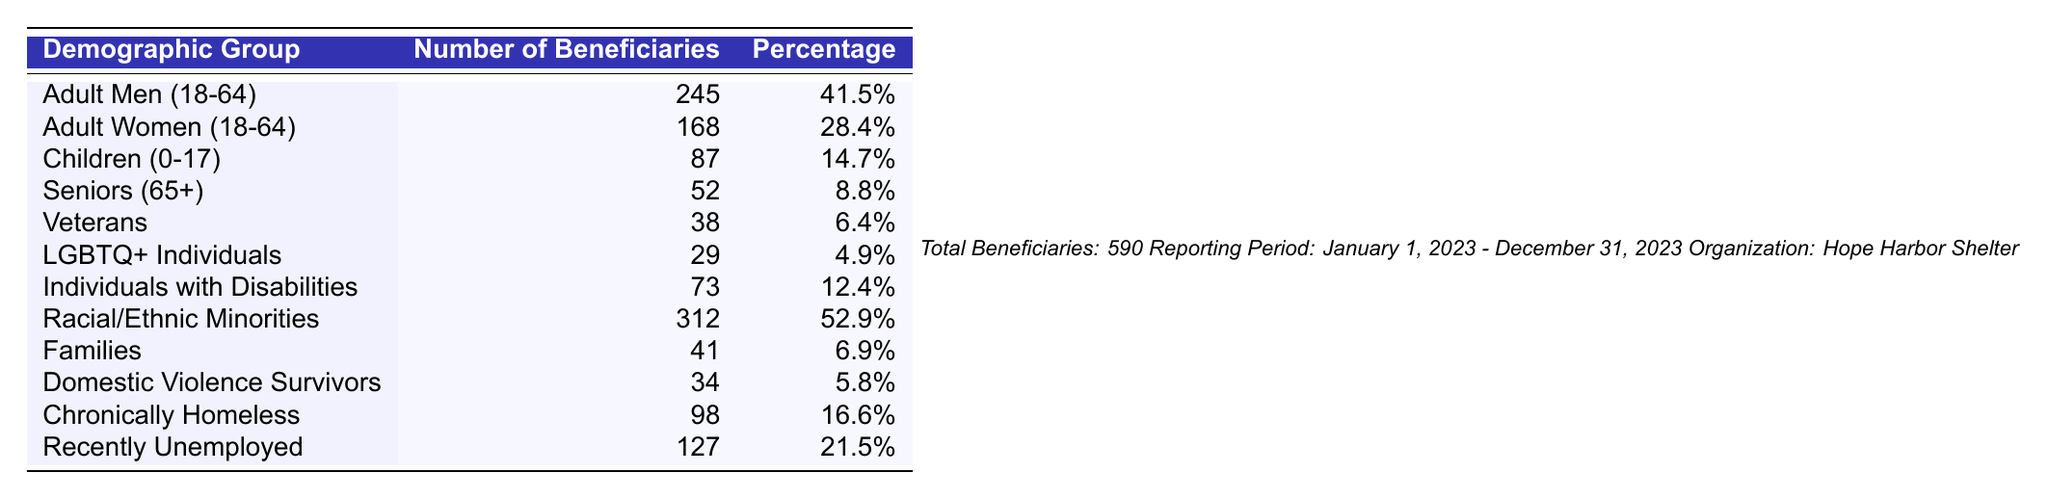What is the total number of beneficiaries served by the Hope Harbor Shelter? The table indicates that the total number of beneficiaries is reported at the bottom, which states "Total Beneficiaries: 590".
Answer: 590 Which demographic group has the highest number of beneficiaries? By examining the numbers in the "Number of Beneficiaries" column, Adult Men (18-64) has the highest at 245.
Answer: Adult Men (18-64) What percentage of beneficiaries are Racial/Ethnic Minorities? The table lists Racial/Ethnic Minorities with a percentage of 52.9% under the "Percentage" column.
Answer: 52.9% How many more Adult Men are served compared to Adult Women? Subtract the number of Adult Women (168) from the number of Adult Men (245): 245 - 168 = 77.
Answer: 77 What is the combined percentage of Children and Seniors served by the shelter? The percentages for Children (14.7%) and Seniors (8.8%) can be summed up: 14.7% + 8.8% = 23.5%.
Answer: 23.5% Are there more veterans or LGBTQ+ individuals served by the shelter? The table shows that there are 38 veterans and 29 LGBTQ+ individuals. Since 38 is greater than 29, the answer is yes.
Answer: Yes What percentage of beneficiaries are either chronically homeless or recently unemployed? Add the percentages for Chronically Homeless (16.6%) and Recently Unemployed (21.5%): 16.6% + 21.5% = 38.1%.
Answer: 38.1% How many beneficiaries are there in the "Individuals with Disabilities" demographic group? The table specifies that there are 73 beneficiaries in the "Individuals with Disabilities" group.
Answer: 73 What is the total percentage accounted for by the ten demographic groups listed? To find the total percentage, sum the percentages from all groups: 41.5% + 28.4% + 14.7% + 8.8% + 6.4% + 4.9% + 12.4% + 52.9% + 6.9% + 5.8% + 16.6% + 21.5% =  338.6%.
Answer: 338.6% Is it true that the percentage of Domestic Violence Survivors is higher than that of Veterans? The table shows Domestic Violence Survivors at 5.8% and Veterans at 6.4%. Since 5.8% is less than 6.4%, the statement is false.
Answer: No 